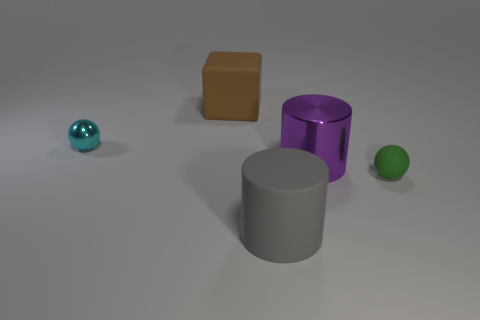Can you describe the shapes and colors of the objects in the image? Certainly, we see a collection of geometric shapes: a teal sphere, a grey cylinder, a purple cylinder, and a brown cube. Each object has a distinct, simple color and a matte finish, arranged on a light neutral surface. 